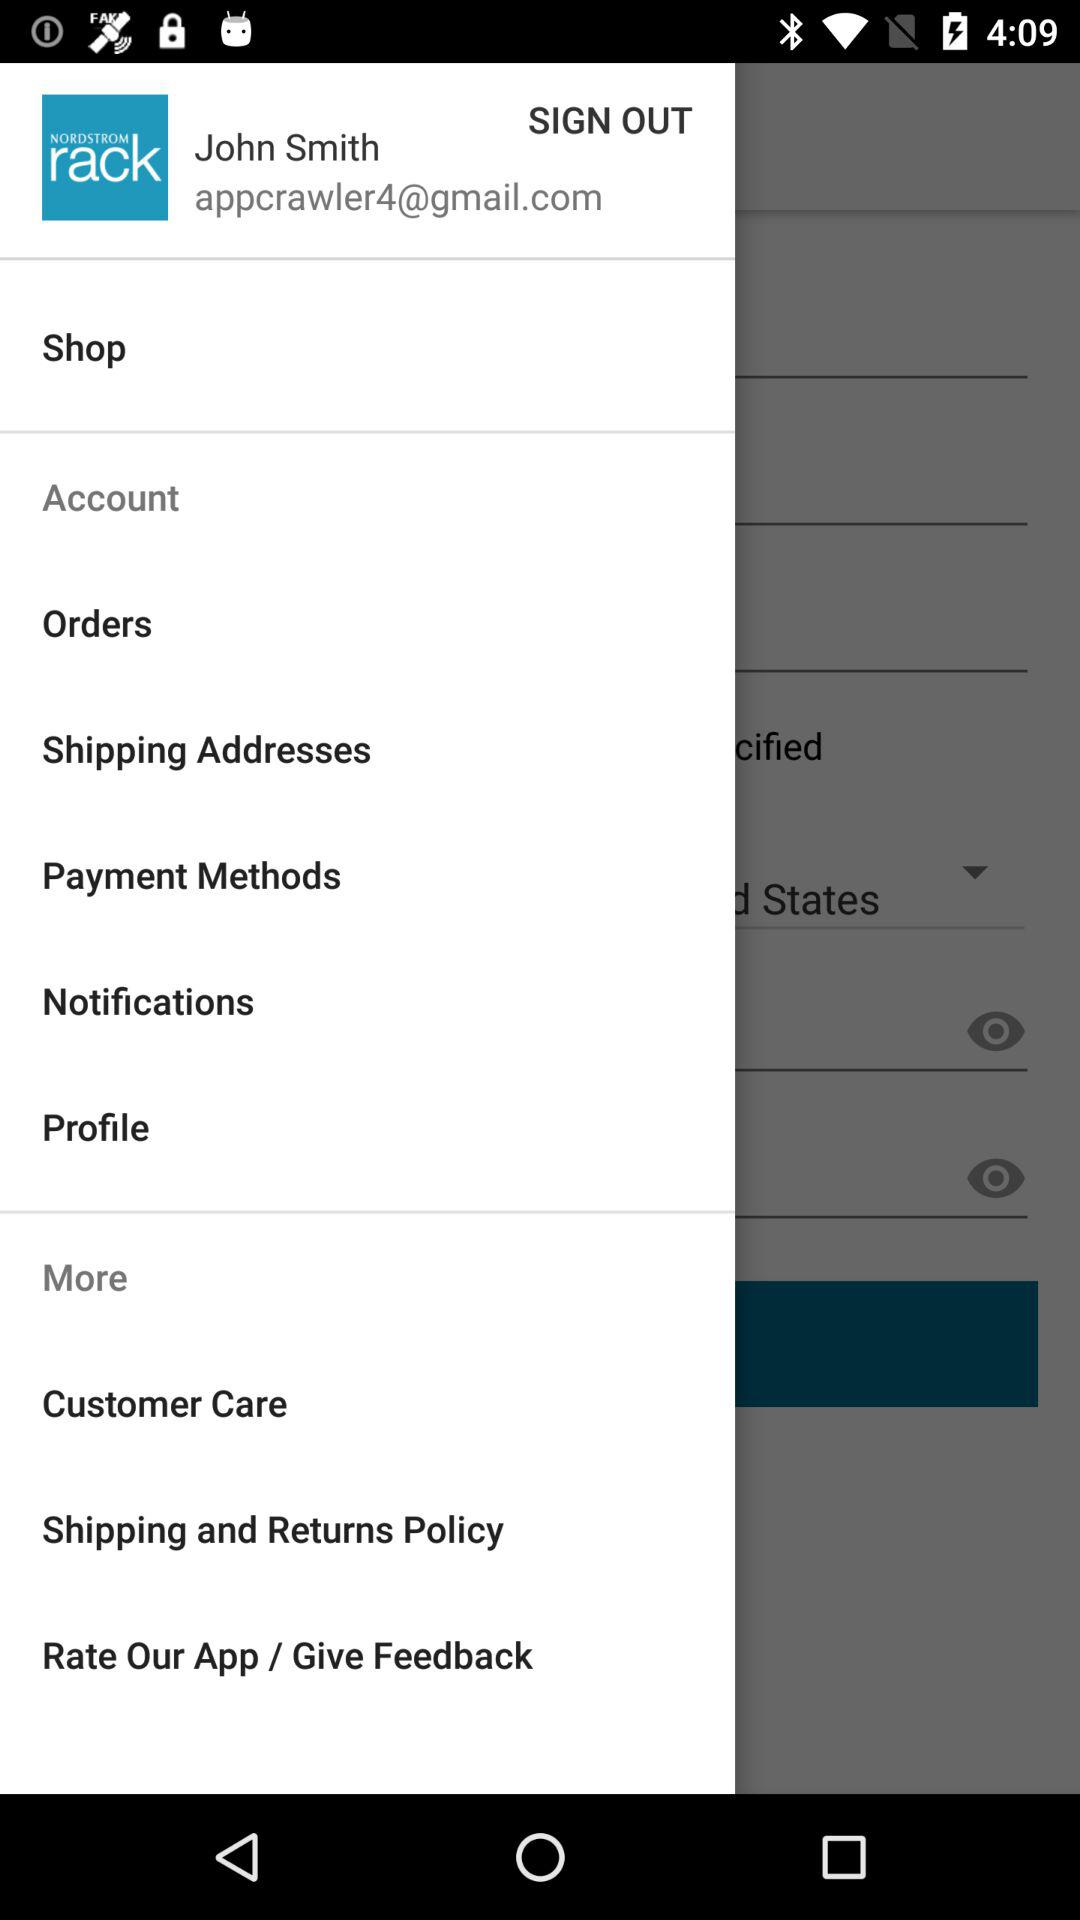Which option is selected?
When the provided information is insufficient, respond with <no answer>. <no answer> 